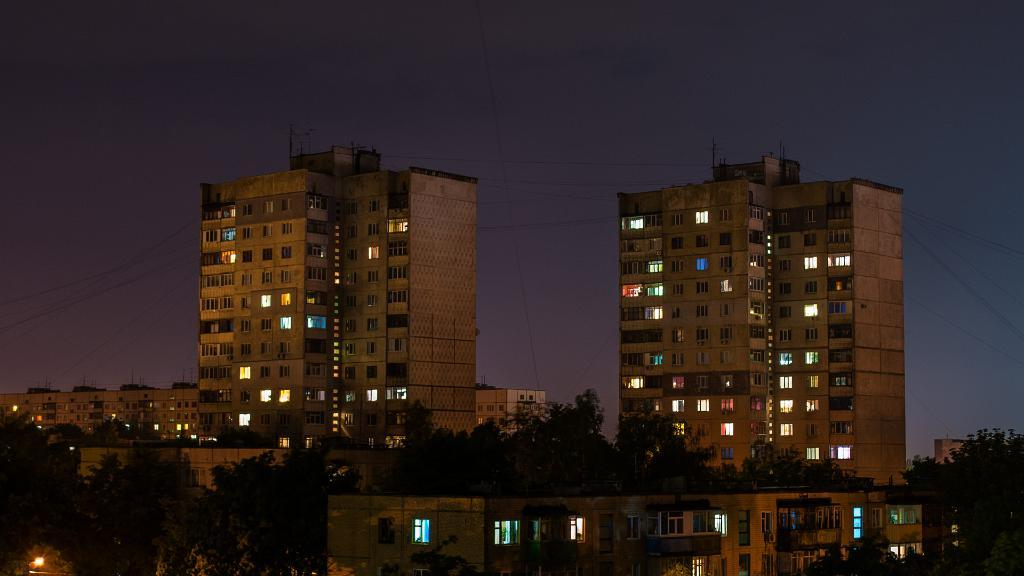What type of structures can be seen in the image? There are buildings in the image. What other natural elements are present in the image? There are trees in the image. Can you describe the lighting in the image? There is light in the image. What can be seen in the background of the image? The sky is visible in the background of the image. What letter is being carried by the tree in the image? There is no letter being carried by the tree in the image, as trees do not carry letters. 